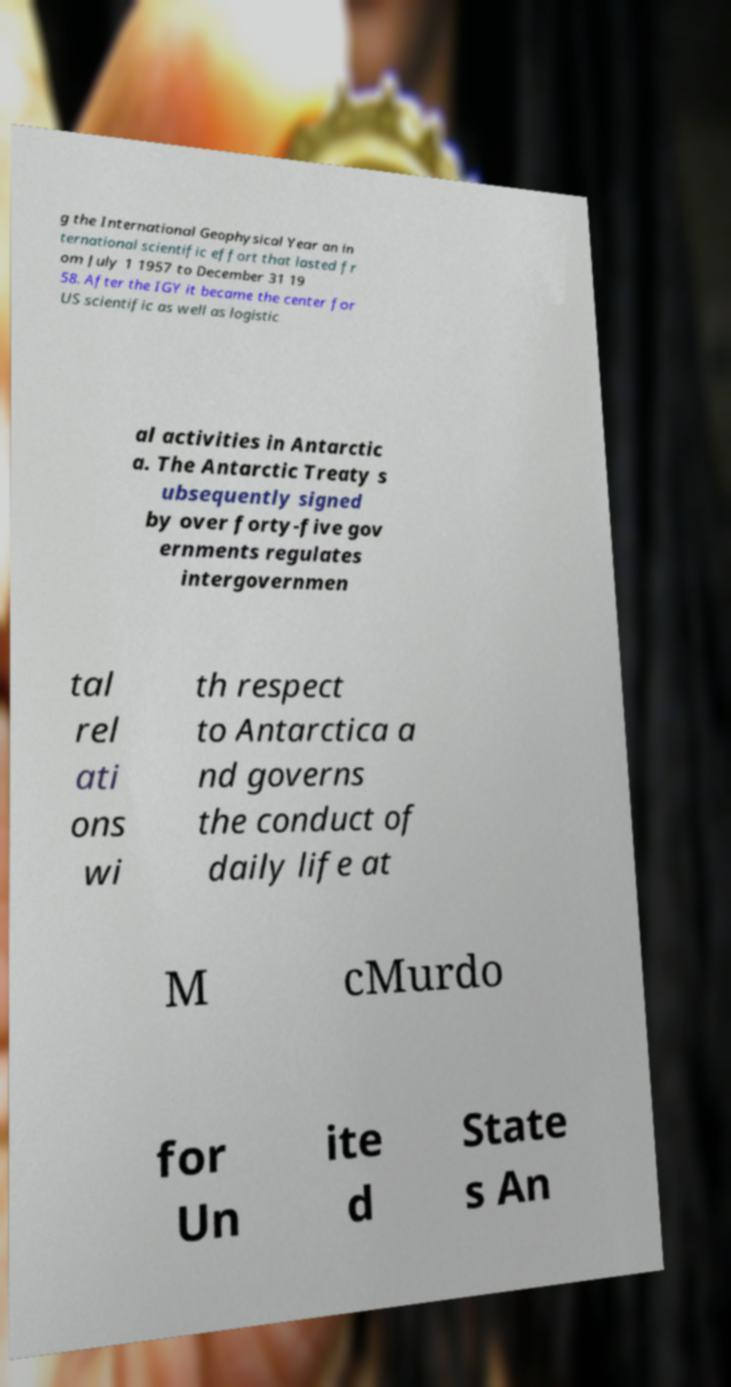Could you assist in decoding the text presented in this image and type it out clearly? g the International Geophysical Year an in ternational scientific effort that lasted fr om July 1 1957 to December 31 19 58. After the IGY it became the center for US scientific as well as logistic al activities in Antarctic a. The Antarctic Treaty s ubsequently signed by over forty-five gov ernments regulates intergovernmen tal rel ati ons wi th respect to Antarctica a nd governs the conduct of daily life at M cMurdo for Un ite d State s An 